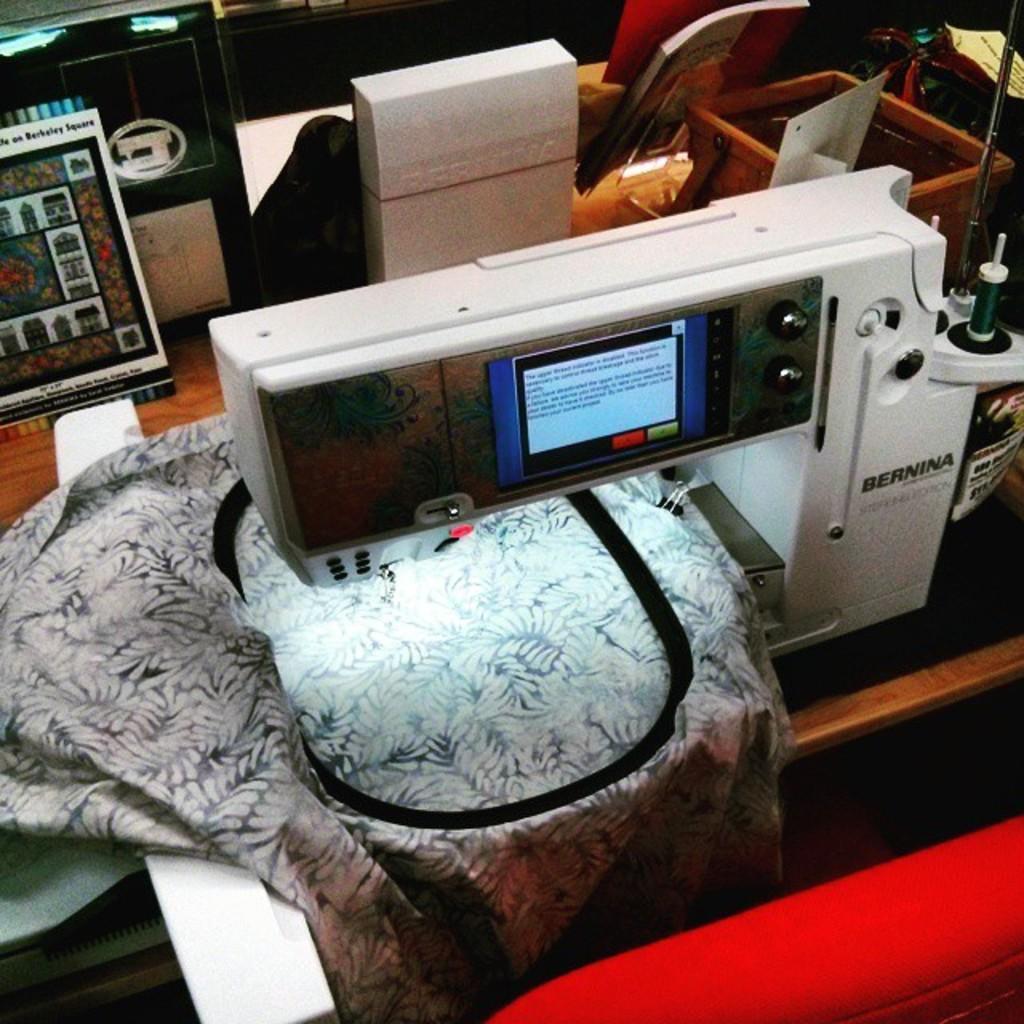Please provide a concise description of this image. In this image I can see many electronic gadgets on the table. To the side I can see the cloths, boards and many objects. 